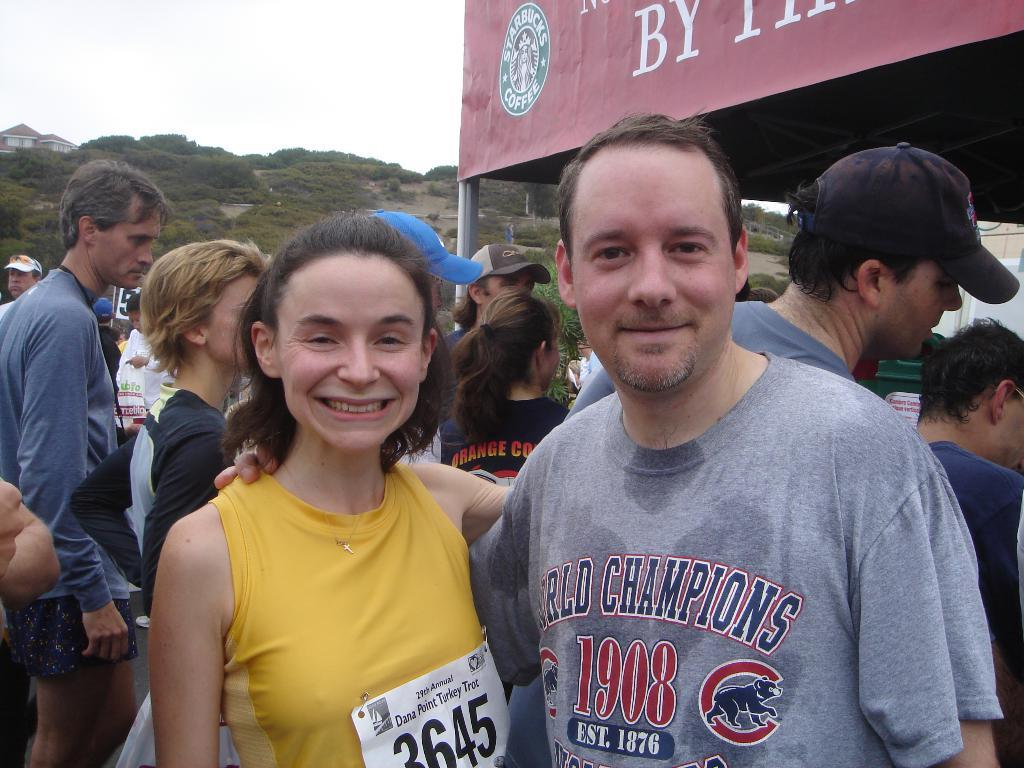How many people are visible in the image? There are two persons standing and smiling in the image. What are the people in the background doing? There is a group of people standing in the background of the image. What can be seen behind the people in the image? There is a stall with a name board, a house, trees, and the sky visible in the background of the image. What type of bun is being served at the coast in the image? There is no bun or coast present in the image. Can you tell me the color of the cat sitting on the house in the image? There is no cat present in the image. 